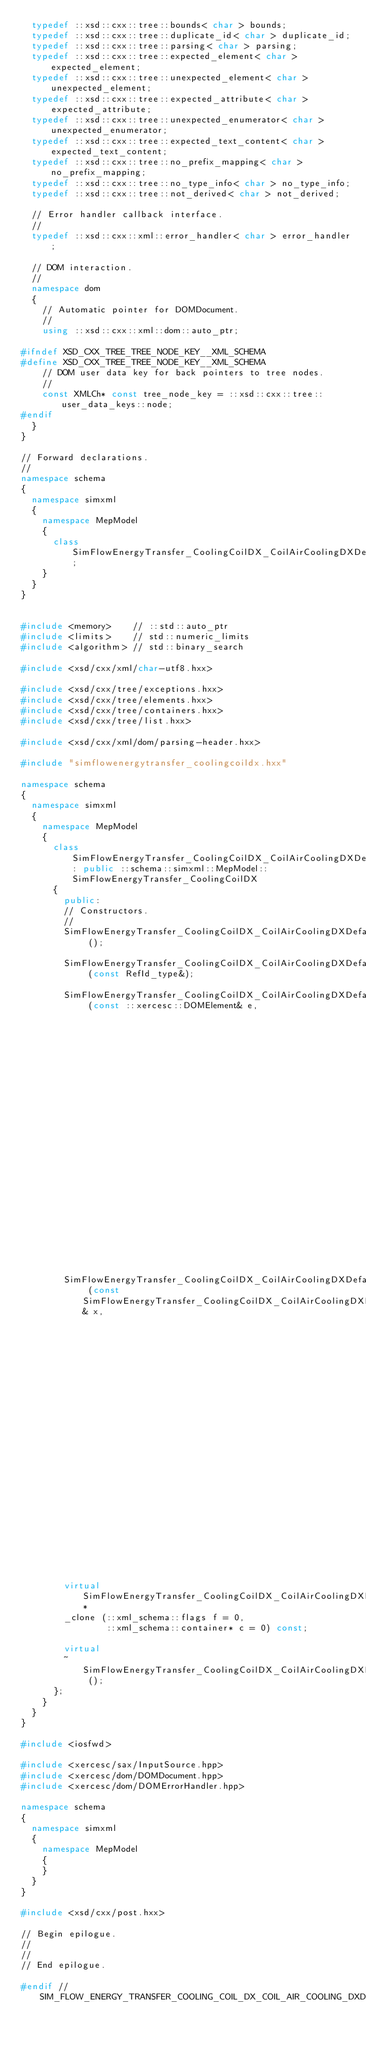Convert code to text. <code><loc_0><loc_0><loc_500><loc_500><_C++_>  typedef ::xsd::cxx::tree::bounds< char > bounds;
  typedef ::xsd::cxx::tree::duplicate_id< char > duplicate_id;
  typedef ::xsd::cxx::tree::parsing< char > parsing;
  typedef ::xsd::cxx::tree::expected_element< char > expected_element;
  typedef ::xsd::cxx::tree::unexpected_element< char > unexpected_element;
  typedef ::xsd::cxx::tree::expected_attribute< char > expected_attribute;
  typedef ::xsd::cxx::tree::unexpected_enumerator< char > unexpected_enumerator;
  typedef ::xsd::cxx::tree::expected_text_content< char > expected_text_content;
  typedef ::xsd::cxx::tree::no_prefix_mapping< char > no_prefix_mapping;
  typedef ::xsd::cxx::tree::no_type_info< char > no_type_info;
  typedef ::xsd::cxx::tree::not_derived< char > not_derived;

  // Error handler callback interface.
  //
  typedef ::xsd::cxx::xml::error_handler< char > error_handler;

  // DOM interaction.
  //
  namespace dom
  {
    // Automatic pointer for DOMDocument.
    //
    using ::xsd::cxx::xml::dom::auto_ptr;

#ifndef XSD_CXX_TREE_TREE_NODE_KEY__XML_SCHEMA
#define XSD_CXX_TREE_TREE_NODE_KEY__XML_SCHEMA
    // DOM user data key for back pointers to tree nodes.
    //
    const XMLCh* const tree_node_key = ::xsd::cxx::tree::user_data_keys::node;
#endif
  }
}

// Forward declarations.
//
namespace schema
{
  namespace simxml
  {
    namespace MepModel
    {
      class SimFlowEnergyTransfer_CoolingCoilDX_CoilAirCoolingDXDefaultCoolingCoil;
    }
  }
}


#include <memory>    // ::std::auto_ptr
#include <limits>    // std::numeric_limits
#include <algorithm> // std::binary_search

#include <xsd/cxx/xml/char-utf8.hxx>

#include <xsd/cxx/tree/exceptions.hxx>
#include <xsd/cxx/tree/elements.hxx>
#include <xsd/cxx/tree/containers.hxx>
#include <xsd/cxx/tree/list.hxx>

#include <xsd/cxx/xml/dom/parsing-header.hxx>

#include "simflowenergytransfer_coolingcoildx.hxx"

namespace schema
{
  namespace simxml
  {
    namespace MepModel
    {
      class SimFlowEnergyTransfer_CoolingCoilDX_CoilAirCoolingDXDefaultCoolingCoil: public ::schema::simxml::MepModel::SimFlowEnergyTransfer_CoolingCoilDX
      {
        public:
        // Constructors.
        //
        SimFlowEnergyTransfer_CoolingCoilDX_CoilAirCoolingDXDefaultCoolingCoil ();

        SimFlowEnergyTransfer_CoolingCoilDX_CoilAirCoolingDXDefaultCoolingCoil (const RefId_type&);

        SimFlowEnergyTransfer_CoolingCoilDX_CoilAirCoolingDXDefaultCoolingCoil (const ::xercesc::DOMElement& e,
                                                                                ::xml_schema::flags f = 0,
                                                                                ::xml_schema::container* c = 0);

        SimFlowEnergyTransfer_CoolingCoilDX_CoilAirCoolingDXDefaultCoolingCoil (const SimFlowEnergyTransfer_CoolingCoilDX_CoilAirCoolingDXDefaultCoolingCoil& x,
                                                                                ::xml_schema::flags f = 0,
                                                                                ::xml_schema::container* c = 0);

        virtual SimFlowEnergyTransfer_CoolingCoilDX_CoilAirCoolingDXDefaultCoolingCoil*
        _clone (::xml_schema::flags f = 0,
                ::xml_schema::container* c = 0) const;

        virtual 
        ~SimFlowEnergyTransfer_CoolingCoilDX_CoilAirCoolingDXDefaultCoolingCoil ();
      };
    }
  }
}

#include <iosfwd>

#include <xercesc/sax/InputSource.hpp>
#include <xercesc/dom/DOMDocument.hpp>
#include <xercesc/dom/DOMErrorHandler.hpp>

namespace schema
{
  namespace simxml
  {
    namespace MepModel
    {
    }
  }
}

#include <xsd/cxx/post.hxx>

// Begin epilogue.
//
//
// End epilogue.

#endif // SIM_FLOW_ENERGY_TRANSFER_COOLING_COIL_DX_COIL_AIR_COOLING_DXDEFAULT_COOLING_COIL_HXX
</code> 